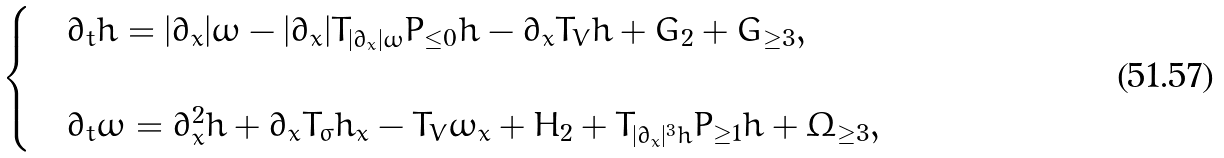<formula> <loc_0><loc_0><loc_500><loc_500>\begin{cases} & \partial _ { t } h = | \partial _ { x } | \omega - | \partial _ { x } | T _ { | \partial _ { x } | \omega } P _ { \leq 0 } h - \partial _ { x } T _ { V } h + G _ { 2 } + G _ { \geq 3 } , \\ \\ & \partial _ { t } \omega = \partial _ { x } ^ { 2 } h + \partial _ { x } T _ { \sigma } h _ { x } - T _ { V } \omega _ { x } + H _ { 2 } + T _ { | \partial _ { x } | ^ { 3 } h } P _ { \geq 1 } h + \Omega _ { \geq 3 } , \end{cases}</formula> 